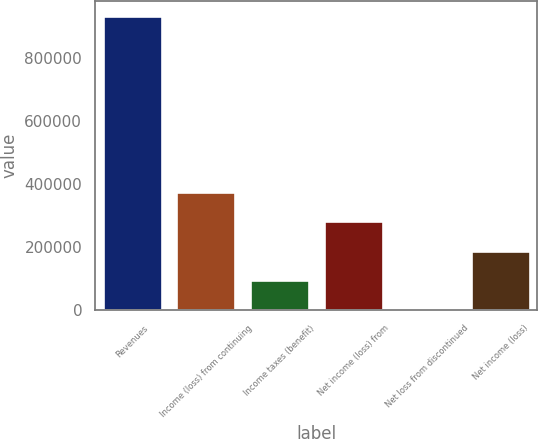<chart> <loc_0><loc_0><loc_500><loc_500><bar_chart><fcel>Revenues<fcel>Income (loss) from continuing<fcel>Income taxes (benefit)<fcel>Net income (loss) from<fcel>Net loss from discontinued<fcel>Net income (loss)<nl><fcel>934852<fcel>375722<fcel>96156.4<fcel>282533<fcel>2968<fcel>189345<nl></chart> 